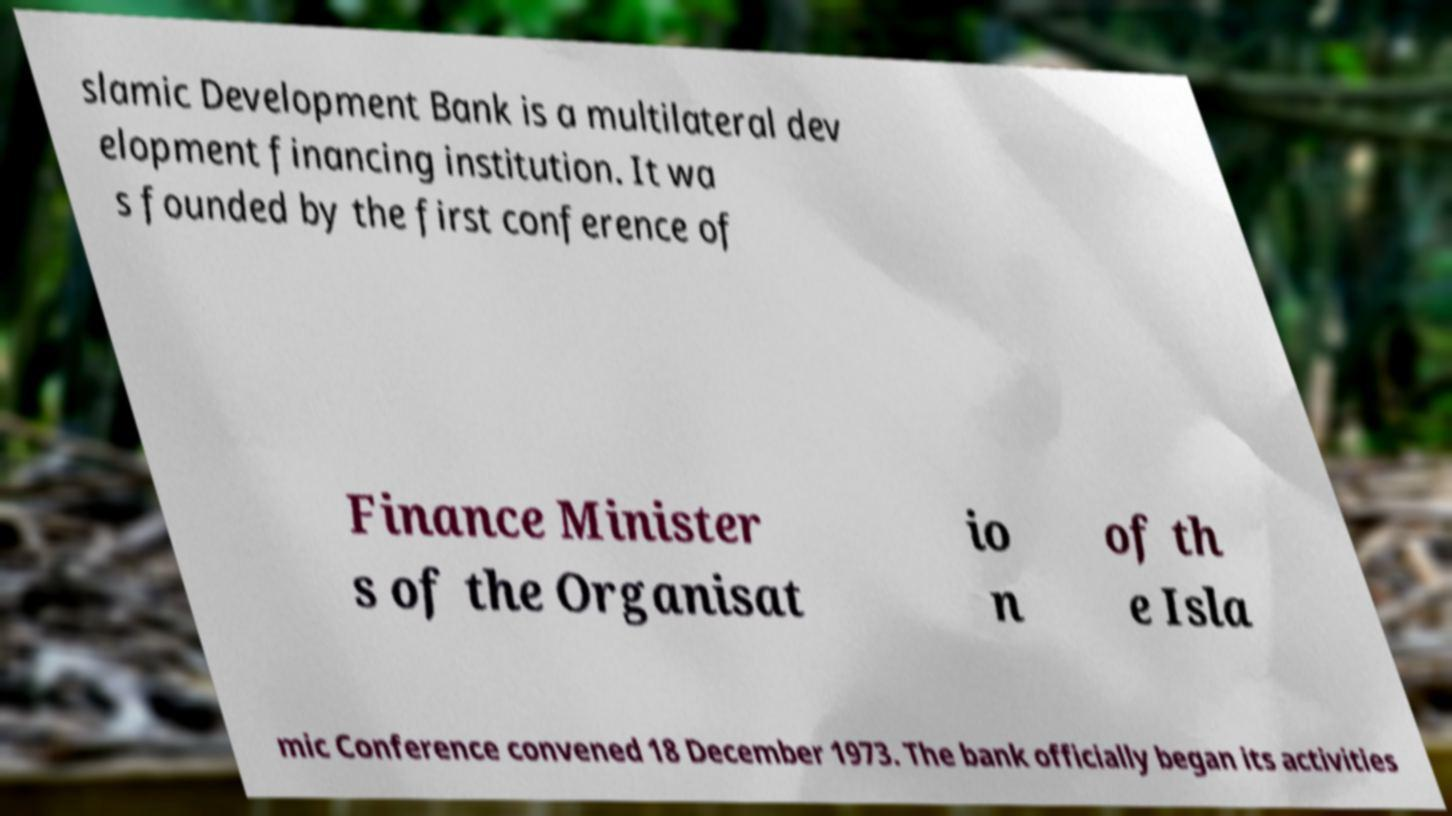Could you extract and type out the text from this image? slamic Development Bank is a multilateral dev elopment financing institution. It wa s founded by the first conference of Finance Minister s of the Organisat io n of th e Isla mic Conference convened 18 December 1973. The bank officially began its activities 